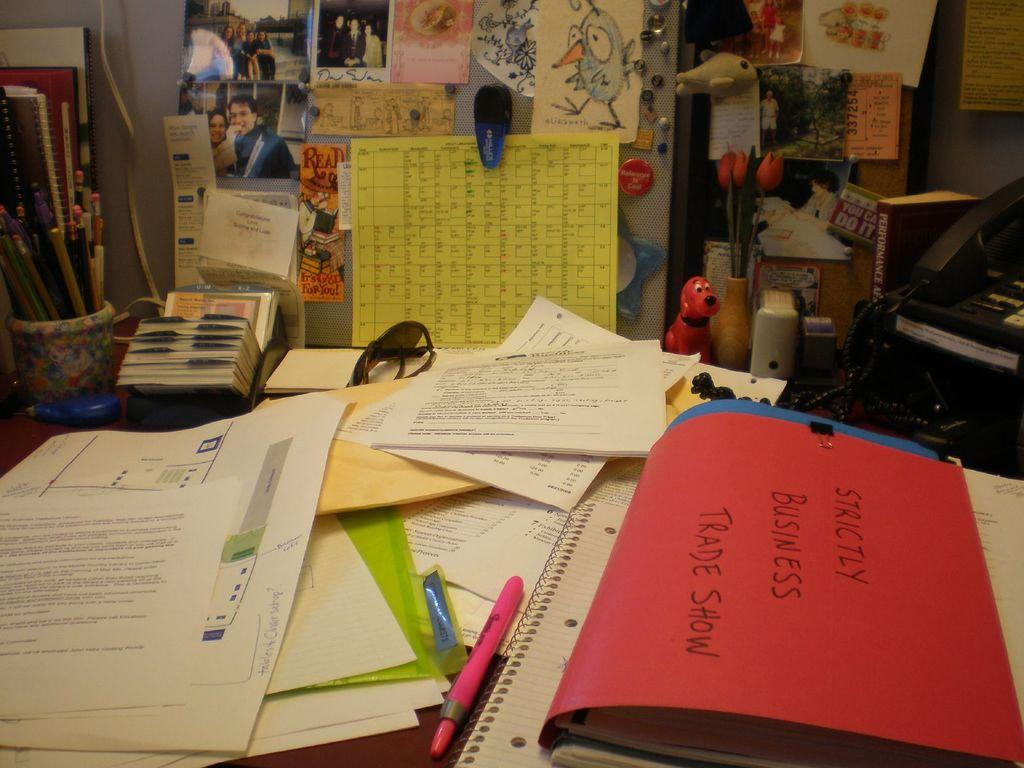Provide a one-sentence caption for the provided image. Strictly business trade show sign on a table. 